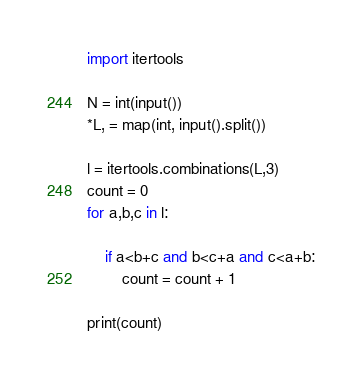<code> <loc_0><loc_0><loc_500><loc_500><_Python_>import itertools

N = int(input())
*L, = map(int, input().split())

l = itertools.combinations(L,3)
count = 0
for a,b,c in l:

    if a<b+c and b<c+a and c<a+b:
        count = count + 1

print(count)</code> 